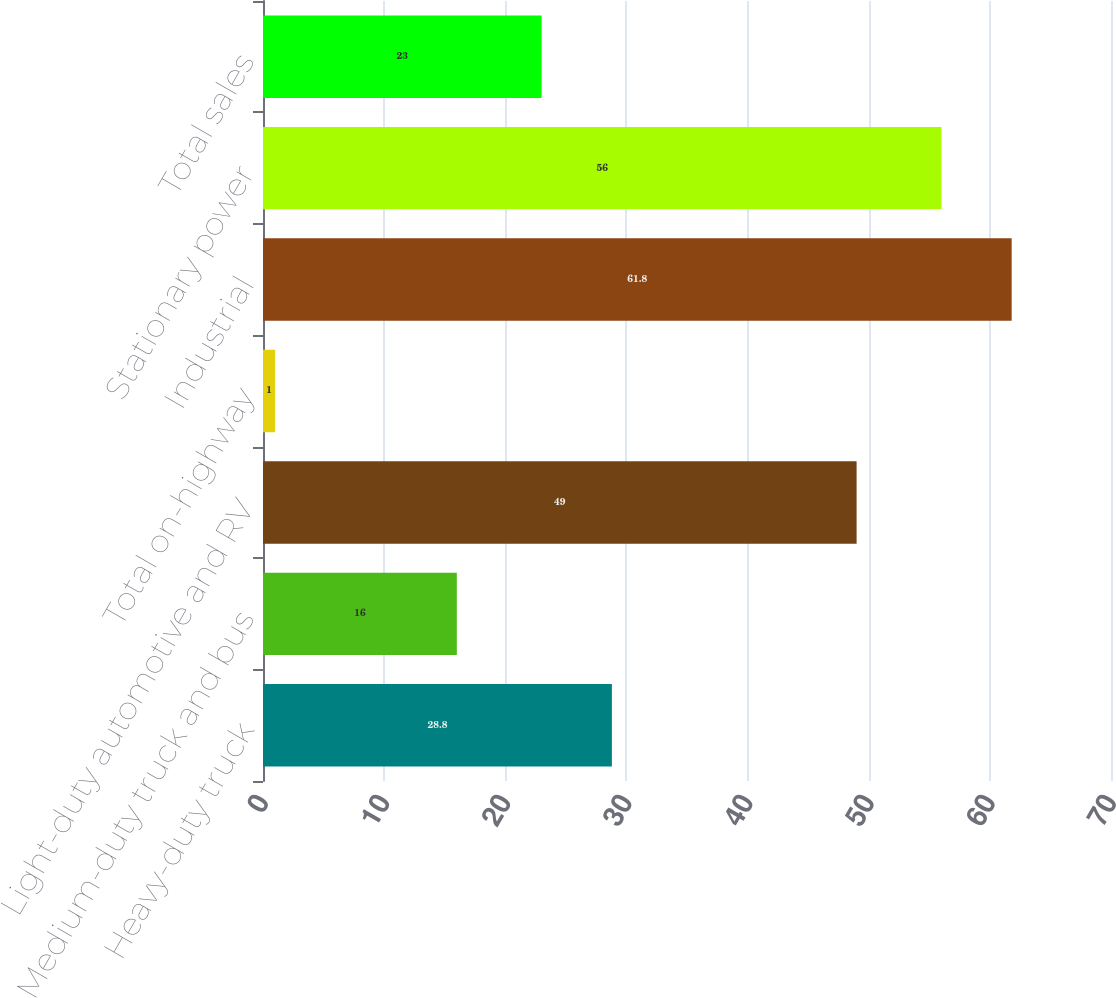Convert chart to OTSL. <chart><loc_0><loc_0><loc_500><loc_500><bar_chart><fcel>Heavy-duty truck<fcel>Medium-duty truck and bus<fcel>Light-duty automotive and RV<fcel>Total on-highway<fcel>Industrial<fcel>Stationary power<fcel>Total sales<nl><fcel>28.8<fcel>16<fcel>49<fcel>1<fcel>61.8<fcel>56<fcel>23<nl></chart> 